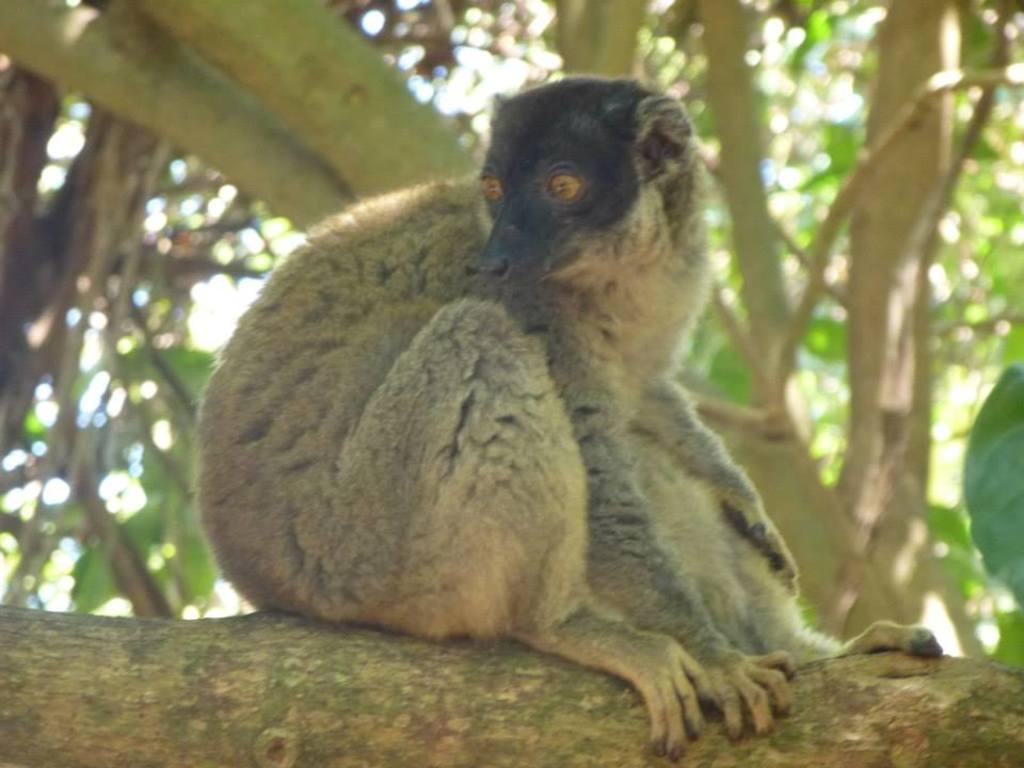What type of creature is in the image? There is an animal in the image, which resembles a monkey. Where is the animal located in the image? The animal is sitting on a branch of a tree. What can be seen in the background of the image? There are trees in the background of the image. What type of oil is being used to measure the animal's weight in the image? There is no oil or measurement of weight present in the image; it simply shows an animal sitting on a tree branch. 